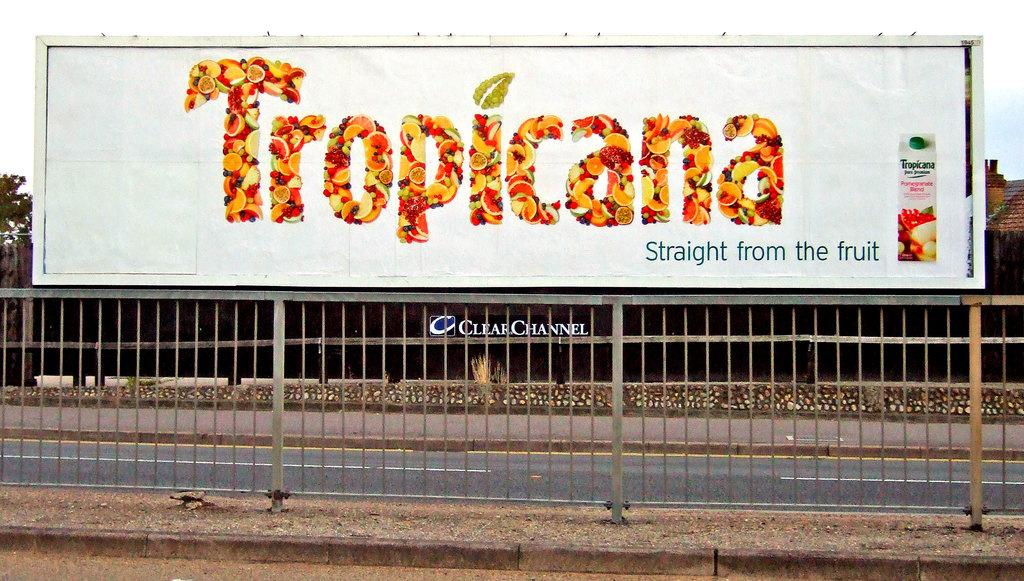Provide a one-sentence caption for the provided image. The logo "straight from the fruit" describes the product on the sign. 